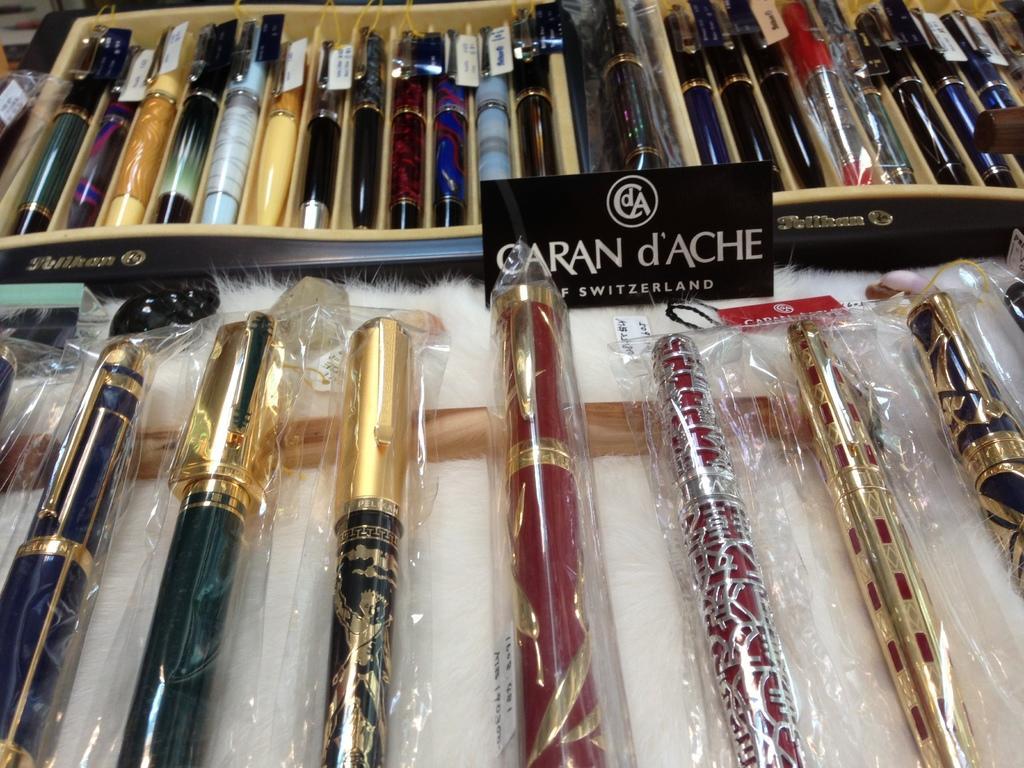In one or two sentences, can you explain what this image depicts? In this image these are pens on a table. 